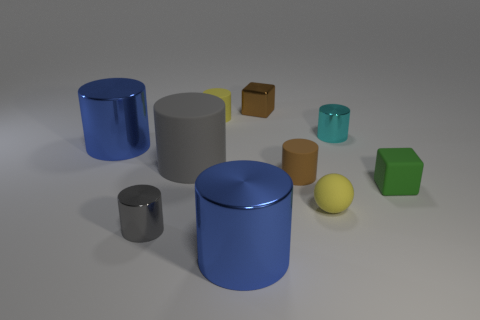There is a brown thing that is the same material as the small gray cylinder; what size is it?
Offer a terse response. Small. Are there more tiny balls that are to the right of the green block than metallic objects that are right of the tiny ball?
Ensure brevity in your answer.  No. Are there any tiny cyan shiny objects that have the same shape as the tiny gray object?
Make the answer very short. Yes. There is a gray metallic object in front of the yellow sphere; does it have the same size as the small brown shiny block?
Your answer should be compact. Yes. Are there any small green cubes?
Make the answer very short. Yes. What number of objects are either small blocks to the right of the cyan shiny thing or green blocks?
Keep it short and to the point. 1. Do the rubber ball and the metallic object on the right side of the small yellow ball have the same color?
Offer a terse response. No. Is there a brown shiny thing of the same size as the gray shiny cylinder?
Keep it short and to the point. Yes. There is a tiny yellow thing on the left side of the brown thing in front of the brown shiny object; what is it made of?
Provide a succinct answer. Rubber. What number of cylinders have the same color as the small rubber block?
Your response must be concise. 0. 